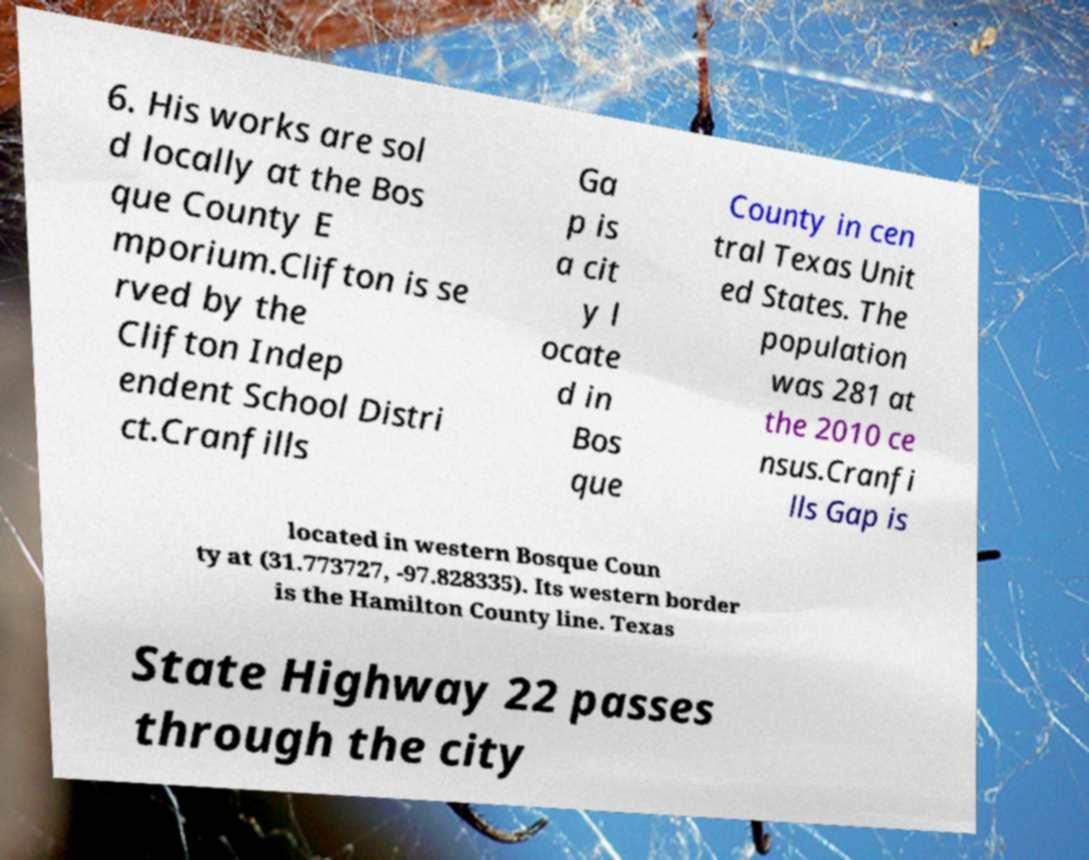Can you read and provide the text displayed in the image?This photo seems to have some interesting text. Can you extract and type it out for me? 6. His works are sol d locally at the Bos que County E mporium.Clifton is se rved by the Clifton Indep endent School Distri ct.Cranfills Ga p is a cit y l ocate d in Bos que County in cen tral Texas Unit ed States. The population was 281 at the 2010 ce nsus.Cranfi lls Gap is located in western Bosque Coun ty at (31.773727, -97.828335). Its western border is the Hamilton County line. Texas State Highway 22 passes through the city 